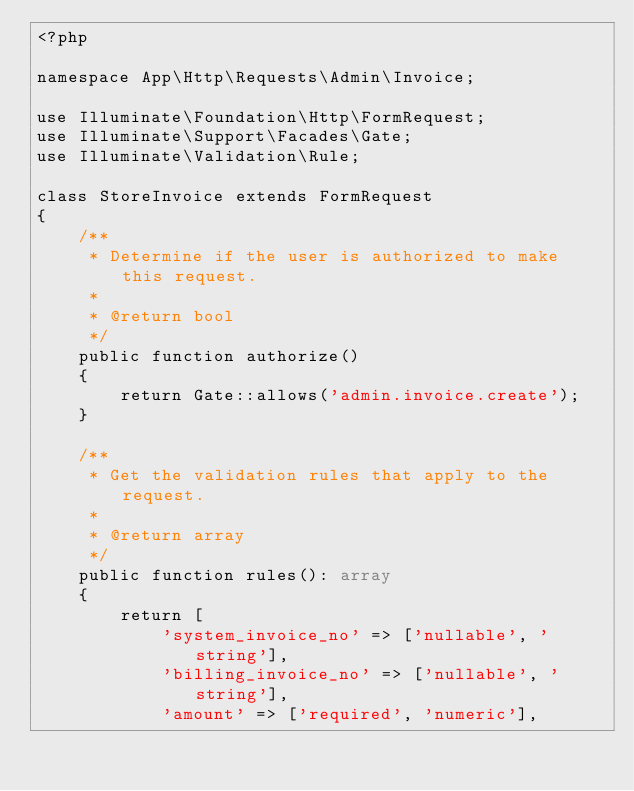Convert code to text. <code><loc_0><loc_0><loc_500><loc_500><_PHP_><?php

namespace App\Http\Requests\Admin\Invoice;

use Illuminate\Foundation\Http\FormRequest;
use Illuminate\Support\Facades\Gate;
use Illuminate\Validation\Rule;

class StoreInvoice extends FormRequest
{
    /**
     * Determine if the user is authorized to make this request.
     *
     * @return bool
     */
    public function authorize()
    {
        return Gate::allows('admin.invoice.create');
    }

    /**
     * Get the validation rules that apply to the request.
     *
     * @return array
     */
    public function rules(): array
    {
        return [
            'system_invoice_no' => ['nullable', 'string'],
            'billing_invoice_no' => ['nullable', 'string'],
            'amount' => ['required', 'numeric'],</code> 